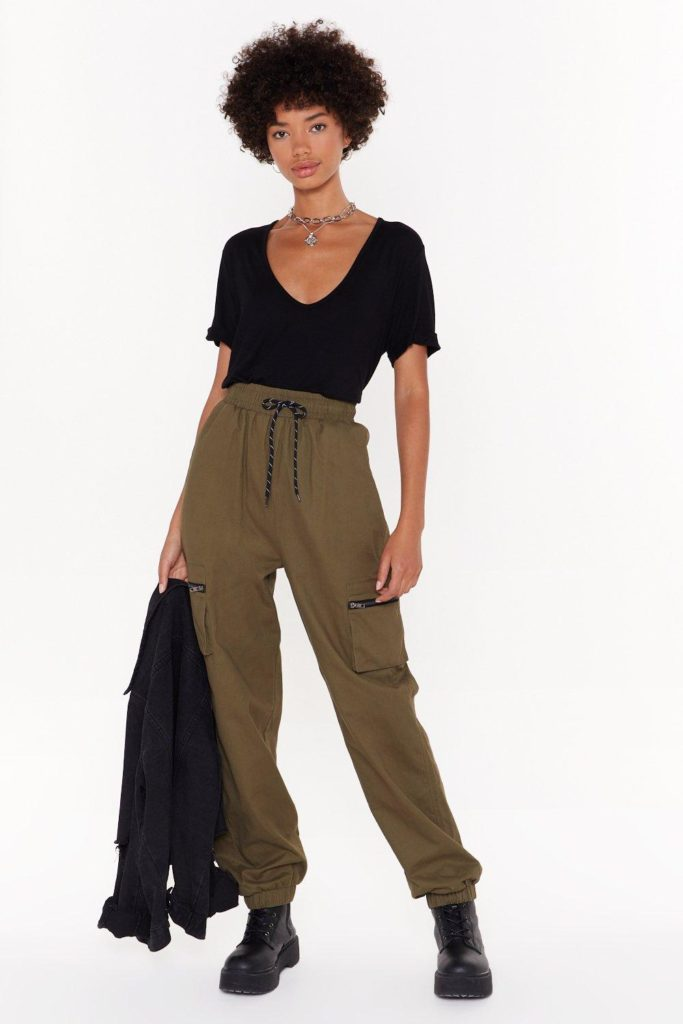Imagine this person's outfit had superpowers. What would each item of clothing's power be? In a world where clothing has superpowers, each item in this person's outfit would have unique abilities. The black t-shirt could have the power of invisibility, allowing the wearer to blend seamlessly into shadows. The olive green cargo pants might provide enhanced agility and strength, enabling the wearer to leap great distances and move swiftly. The black boots could give the power of indomitable balance and stability, allowing for flawless navigation across any terrain, no matter how treacherous. The denim jacket, when worn, could serve as an impenetrable shield, offering protection against any physical threat or elemental force. 